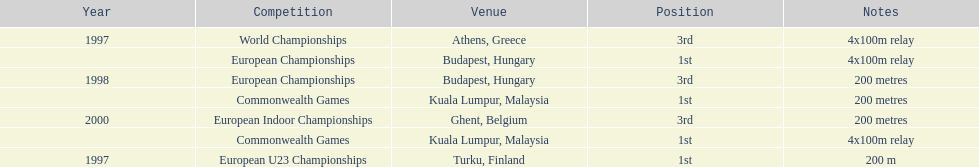How many total years did golding compete? 3. 